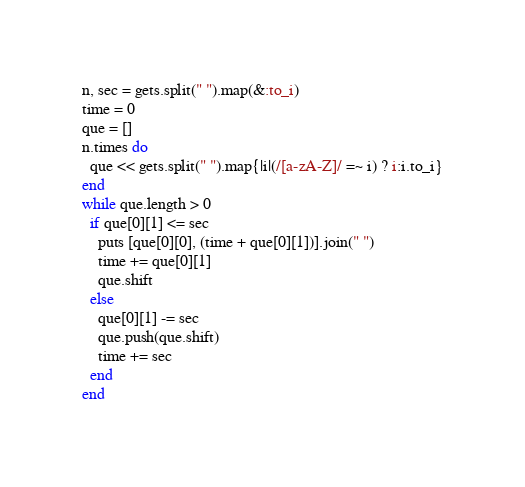<code> <loc_0><loc_0><loc_500><loc_500><_Ruby_>n, sec = gets.split(" ").map(&:to_i)
time = 0
que = []
n.times do
  que << gets.split(" ").map{|i|(/[a-zA-Z]/ =~ i) ? i:i.to_i}
end
while que.length > 0
  if que[0][1] <= sec
    puts [que[0][0], (time + que[0][1])].join(" ")
    time += que[0][1]
    que.shift
  else
    que[0][1] -= sec
    que.push(que.shift)
    time += sec
  end
end</code> 